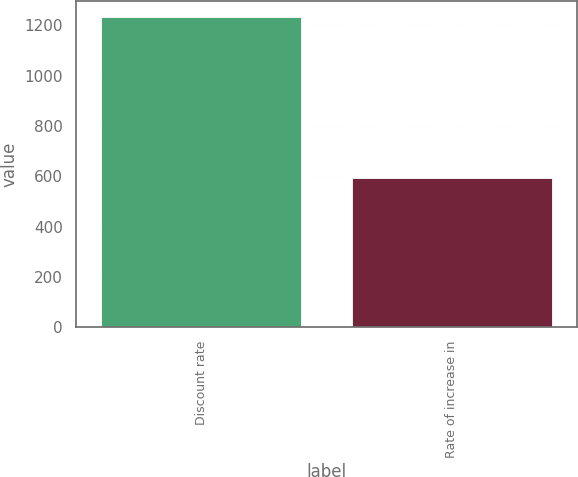<chart> <loc_0><loc_0><loc_500><loc_500><bar_chart><fcel>Discount rate<fcel>Rate of increase in<nl><fcel>1234<fcel>593<nl></chart> 